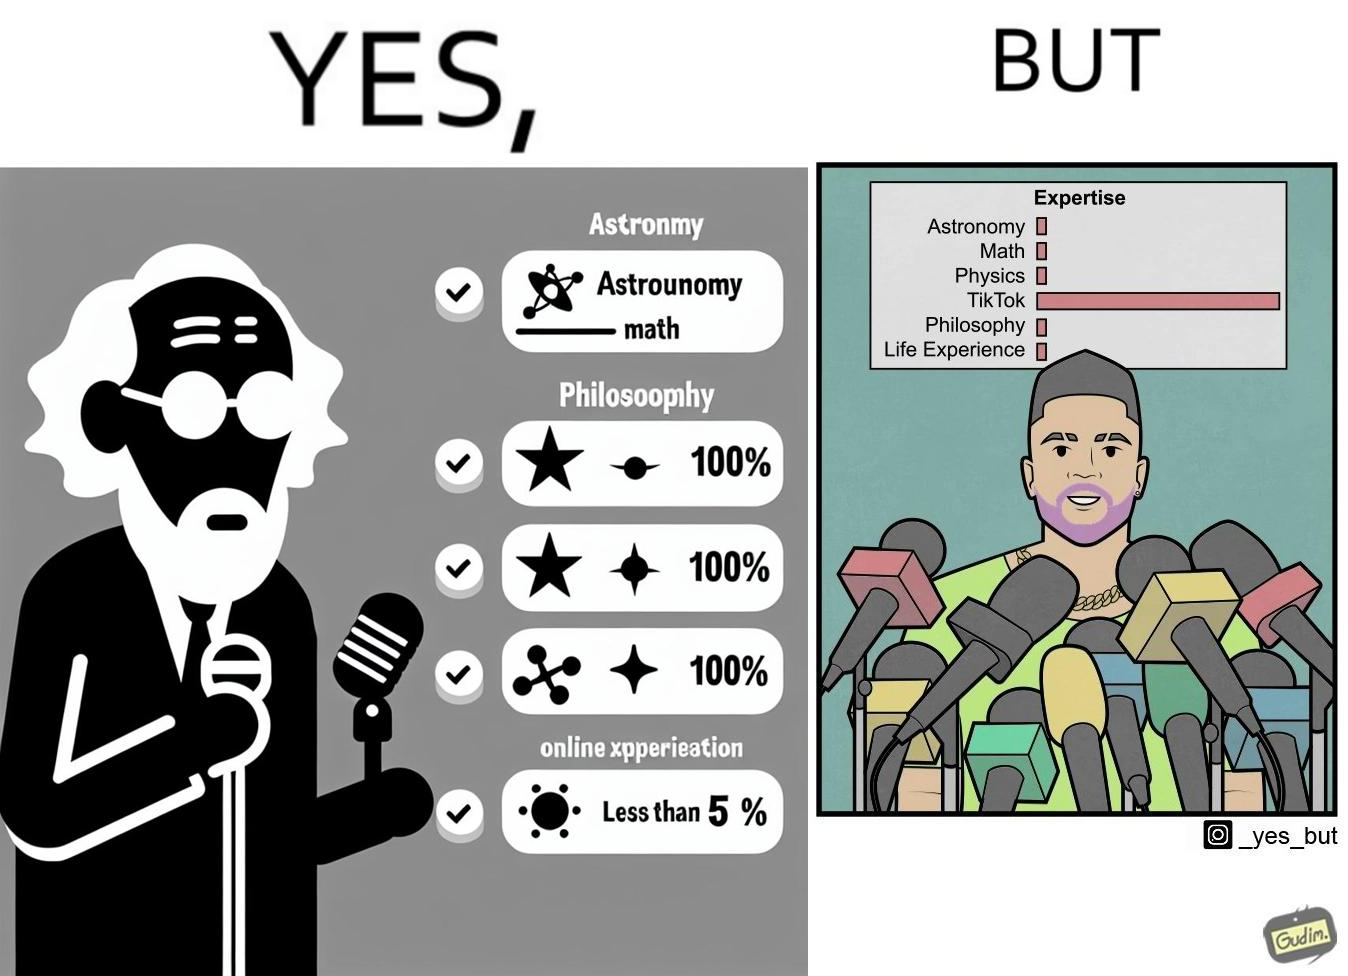Describe what you see in the left and right parts of this image. In the left part of the image: The image shows an old man speaking into a microphone. The image also shows the man's expertise in several areas such as Astronomy, Math, Physics, TikTok, Philosophy and Life Experience. The man has 100% exepertise in all the areas except Tik Tok where he has less than 5% exepertise. In the right part of the image: The image shows a you man speaking into several microphones. The image also shows the man's expertise in several areas such as Astronomy, Math, Physics, TikTok, Philosophy and Life Experience. The man has  less than 5% exepertise in all the areas except Tik Tok where he has 100% expertise. 